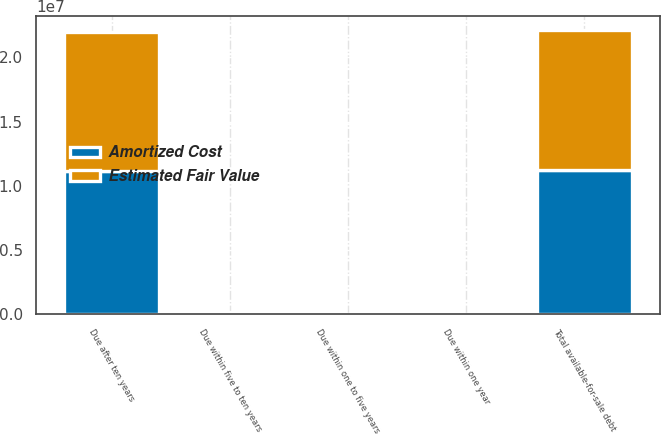<chart> <loc_0><loc_0><loc_500><loc_500><stacked_bar_chart><ecel><fcel>Due within one year<fcel>Due within one to five years<fcel>Due within five to ten years<fcel>Due after ten years<fcel>Total available-for-sale debt<nl><fcel>Amortized Cost<fcel>12086<fcel>488<fcel>78159<fcel>1.11542e+07<fcel>1.1245e+07<nl><fcel>Estimated Fair Value<fcel>14212<fcel>482<fcel>76613<fcel>1.0789e+07<fcel>1.08803e+07<nl></chart> 